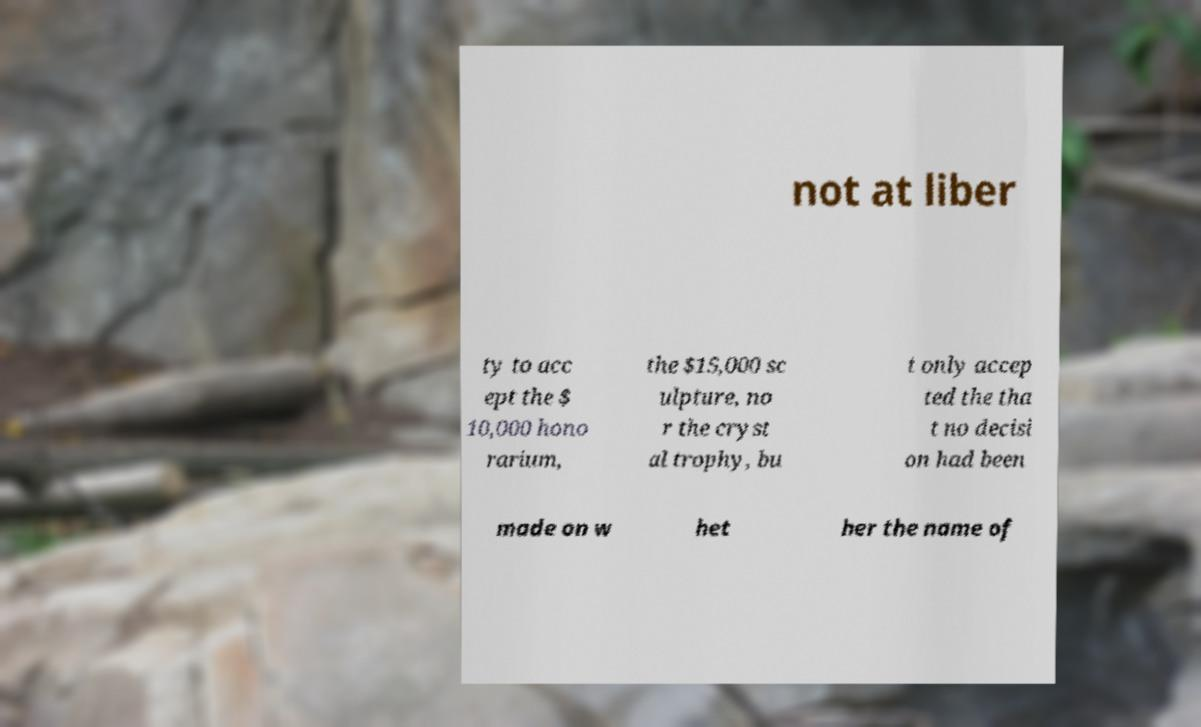Could you assist in decoding the text presented in this image and type it out clearly? not at liber ty to acc ept the $ 10,000 hono rarium, the $15,000 sc ulpture, no r the cryst al trophy, bu t only accep ted the tha t no decisi on had been made on w het her the name of 